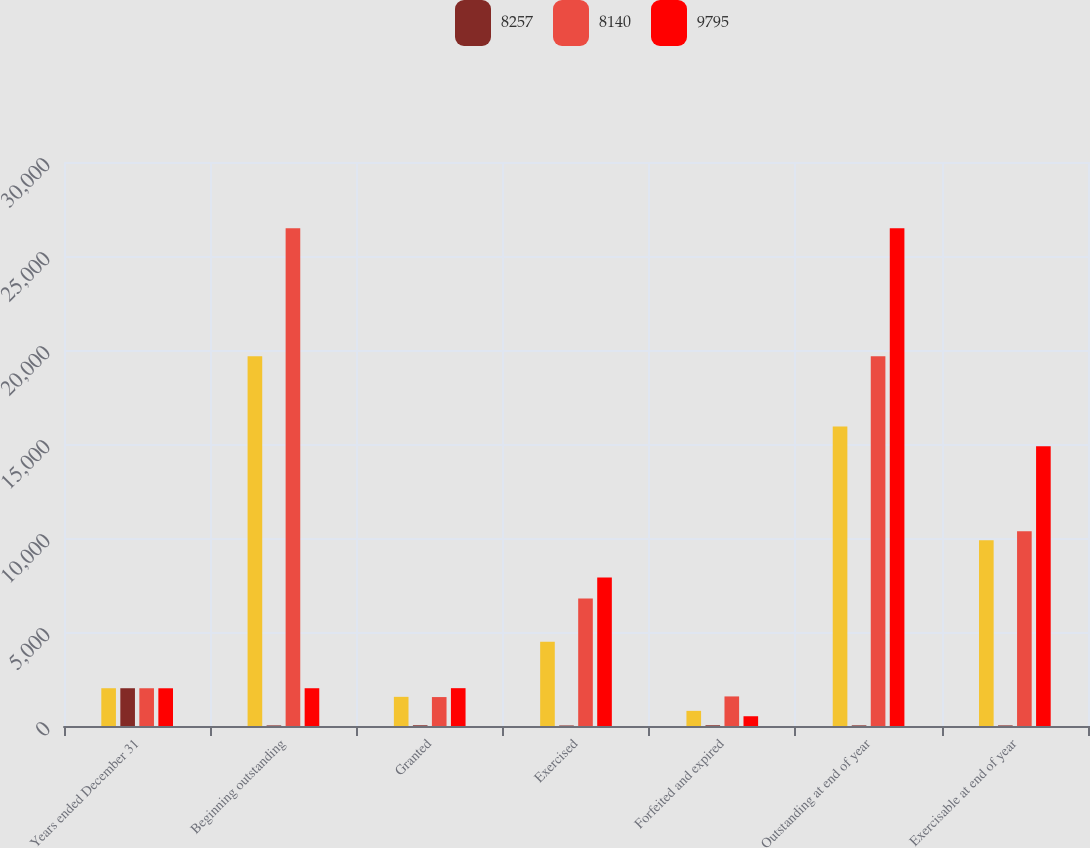Convert chart. <chart><loc_0><loc_0><loc_500><loc_500><stacked_bar_chart><ecel><fcel>Years ended December 31<fcel>Beginning outstanding<fcel>Granted<fcel>Exercised<fcel>Forfeited and expired<fcel>Outstanding at end of year<fcel>Exercisable at end of year<nl><fcel>nan<fcel>2009<fcel>19666<fcel>1551<fcel>4475<fcel>805<fcel>15937<fcel>9884<nl><fcel>8257<fcel>2009<fcel>31<fcel>38<fcel>27<fcel>38<fcel>33<fcel>31<nl><fcel>8140<fcel>2008<fcel>26479<fcel>1539<fcel>6779<fcel>1573<fcel>19666<fcel>10357<nl><fcel>9795<fcel>2007<fcel>2009<fcel>2012<fcel>7903<fcel>519<fcel>26479<fcel>14880<nl></chart> 